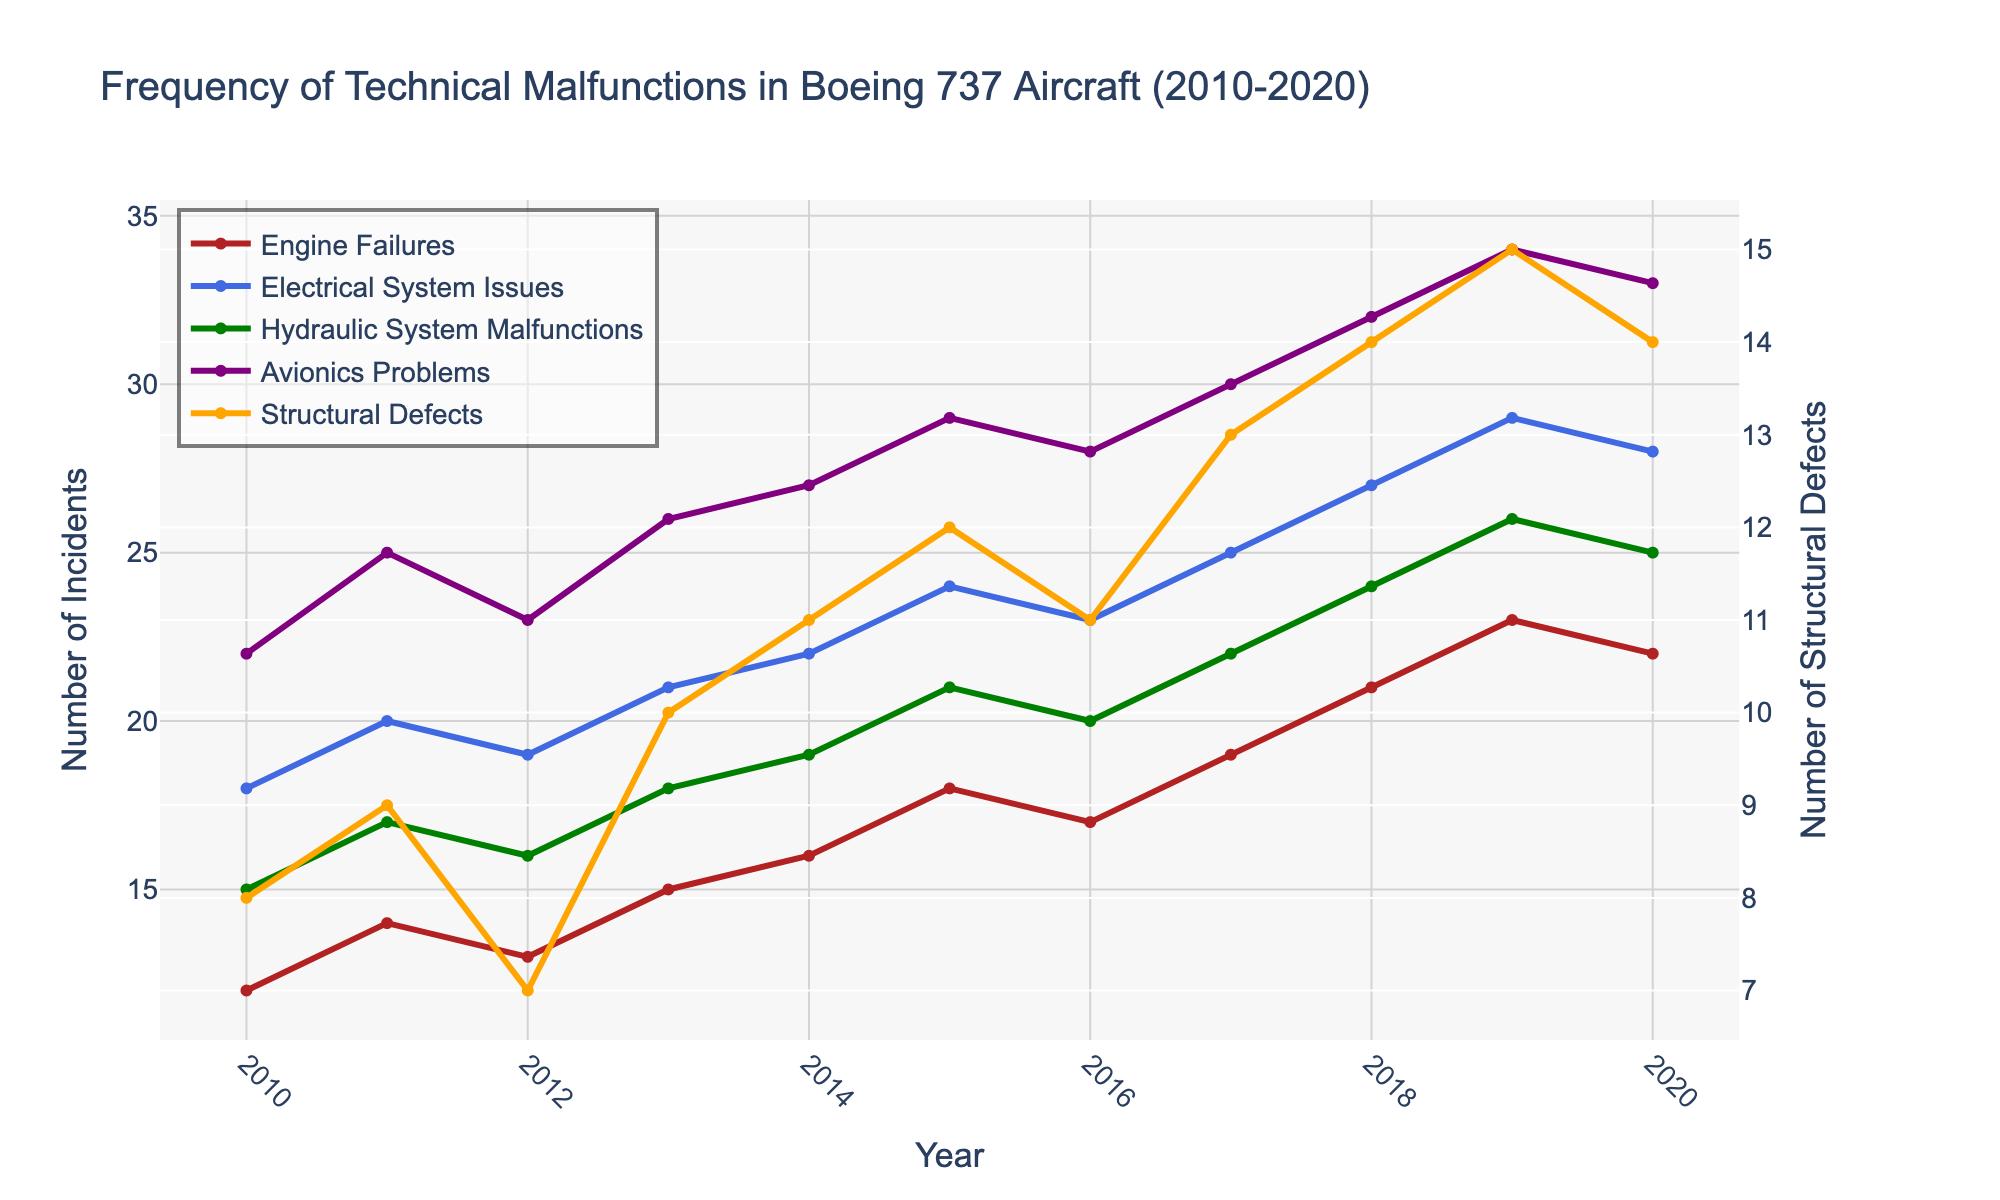Which year had the highest number of Engine Failures? To answer this question, we need to identify the maximum point on the "Engine Failures" line. The highest point occurs in 2019 with 23 incidents.
Answer: 2019 Which type of malfunction consistently showed an increase from 2010 to 2020? We have to check each type of malfunction and see if their numbers increased every year. Upon inspection, "Avionics Problems" consistently show an increase from 2010 to 2020.
Answer: Avionics Problems What is the total number of Electrical System Issues and Hydraulic System Malfunctions in 2015? We need to add the values for Electrical System Issues (24) and Hydraulic System Malfunctions (21) in 2015. So, the total is 24 + 21 = 45.
Answer: 45 Compare the number of Structural Defects between 2013 and 2020. Which year had more, and by how many? In 2013, there were 10 Structural Defects and in 2020, there were 14. The difference is 14 - 10 = 4, so 2020 had 4 more Structural Defects than 2013.
Answer: 2020, by 4 What is the average number of Engine Failures across the years? To find the average, sum up the Engine Failures from 2010 to 2020 and divide by the number of years (11). The sum is 12 + 14 + 13 + 15 + 16 + 18 + 17 + 19 + 21 + 23 + 22 = 190. The average is 190 / 11 ≈ 17.27.
Answer: 17.27 Which year had the lowest number of Structural Defects and how many were there? We need to identify the lowest point on the "Structural Defects" line, which corresponds to the year with the lowest value. The lowest point occurs in 2012, with 7 incidents.
Answer: 2012, with 7 In which years did the Avionics Problems exceed 30 incidents? Check the plot for the "Avionics Problems" line and look for years where the value is above 30. The line exceeds 30 incidents in the years 2018, 2019, and 2020.
Answer: 2018, 2019, 2020 What is the difference in the number of Hydraulic System Malfunctions between the highest and lowest years? Identify the years with the highest and lowest Hydraulic System Malfunctions: 2019 (26) and 2010 (15) respectively. The difference is 26 - 15 = 11.
Answer: 11 